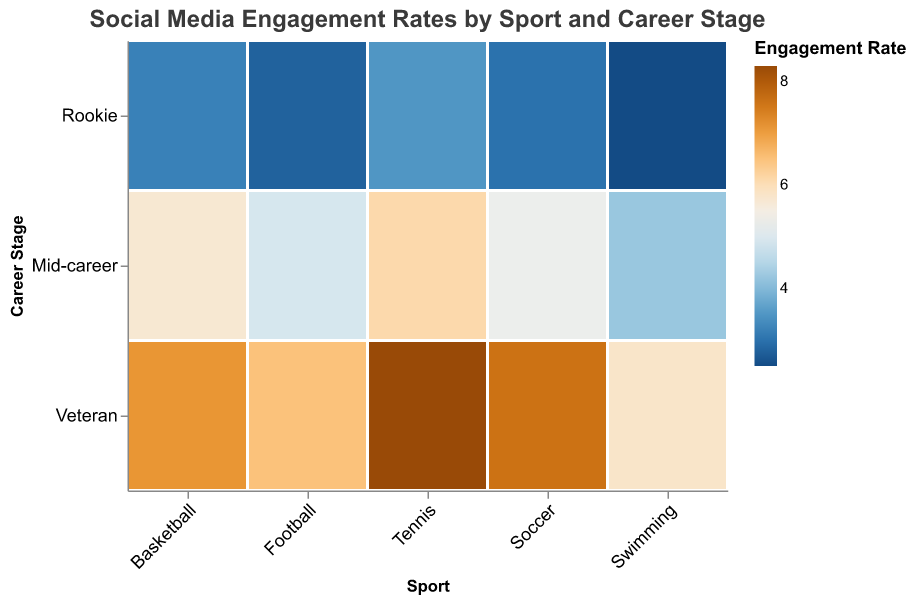What is the title of the figure? The title is located at the top of the figure and usually indicates what the chart is about. The title in this case is "Social Media Engagement Rates by Sport and Career Stage."
Answer: Social Media Engagement Rates by Sport and Career Stage Which sport has the highest engagement rate for veterans? Look at the column labeled "Veteran" for each sport and compare the colors. Tennis has the darkest shade, indicating the highest engagement rate at 8.3%.
Answer: Tennis What is the engagement rate for rookie football players? Find the intersection of Football with the Rookie row and check the color-encoded engagement rate. It is 2.8%.
Answer: 2.8 How do engagement rates for mid-career athletes in soccer compare to those in swimming? Look at the Mid-career row and compare the columns for Soccer and Swimming. Soccer has an engagement rate of 5.3%, while Swimming has 4.2%.
Answer: Soccer has a higher engagement rate than Swimming Which stage of a basketball player's career has the highest engagement rate? Check the engagement rates for Basketball across Rookie, Mid-career, and Veteran. The Veteran career stage has the highest engagement rate at 7.1%.
Answer: Veteran Which sport has the lowest engagement rate at the Rookie stage? Look at the Rookie row and identify the sport with the lightest color. Swimming has the lowest engagement rate at 2.5%.
Answer: Swimming What is the difference in engagement rate between veteran football players and mid-career basketball players? Find the engagement rates for Veteran football (6.5%) and Mid-career basketball (5.7%), then subtract the latter from the former. 6.5 - 5.7 = 0.8.
Answer: 0.8 How does the engagement rate for mid-career tennis players compare to mid-career soccer players? Check the engagement rates in the Mid-career row for Tennis (6.1%) and Soccer (5.3%), then compare them.
Answer: Tennis has a higher engagement rate than Soccer Which career stage generally has the highest engagement rates across all sports? Review the engagement rates for Rookie, Mid-career, and Veteran stages across all sports. The Veteran stage has consistently high rates.
Answer: Veteran Is the engagement rate for Rookie basketball players higher or lower than for Rookie soccer players? Compare the engagement rates for Rookie Basketball (3.2%) and Rookie Soccer (3.0%). Basketball has a slightly higher rate.
Answer: Higher 